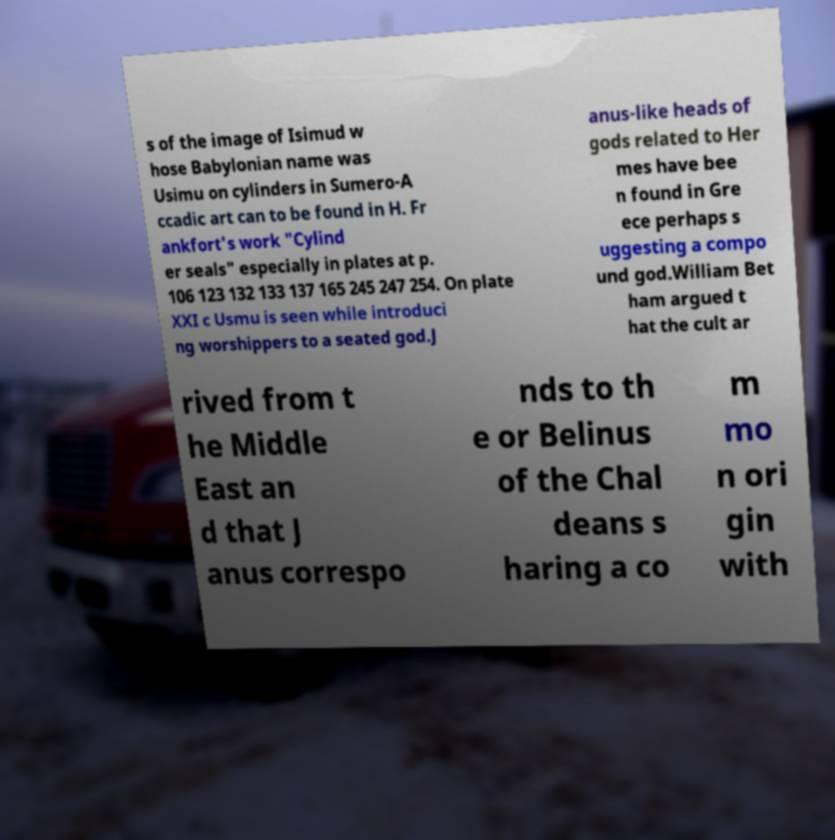Please identify and transcribe the text found in this image. s of the image of Isimud w hose Babylonian name was Usimu on cylinders in Sumero-A ccadic art can to be found in H. Fr ankfort's work "Cylind er seals" especially in plates at p. 106 123 132 133 137 165 245 247 254. On plate XXI c Usmu is seen while introduci ng worshippers to a seated god.J anus-like heads of gods related to Her mes have bee n found in Gre ece perhaps s uggesting a compo und god.William Bet ham argued t hat the cult ar rived from t he Middle East an d that J anus correspo nds to th e or Belinus of the Chal deans s haring a co m mo n ori gin with 